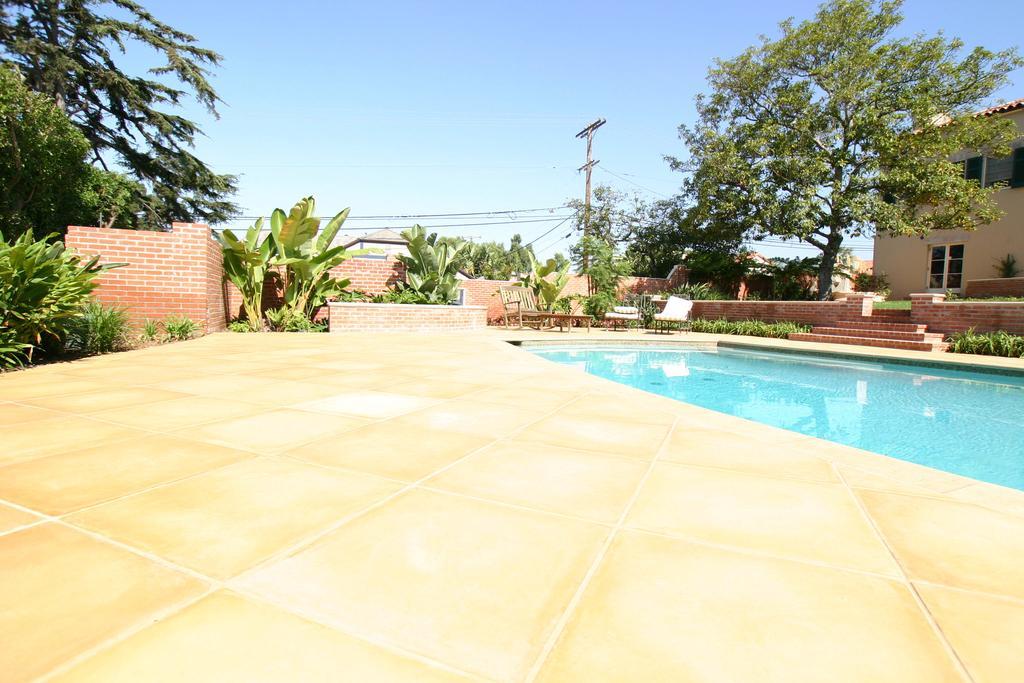Please provide a concise description of this image. In this image there is a building, in front of the building there is a swimming pool and there are a few chairs and tables arranged, there are trees, plants, fencing wall, behind that there is a utility pole. In the background there is the sky. 